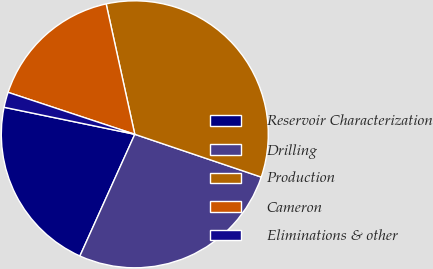<chart> <loc_0><loc_0><loc_500><loc_500><pie_chart><fcel>Reservoir Characterization<fcel>Drilling<fcel>Production<fcel>Cameron<fcel>Eliminations & other<nl><fcel>21.5%<fcel>26.55%<fcel>33.63%<fcel>16.47%<fcel>1.84%<nl></chart> 